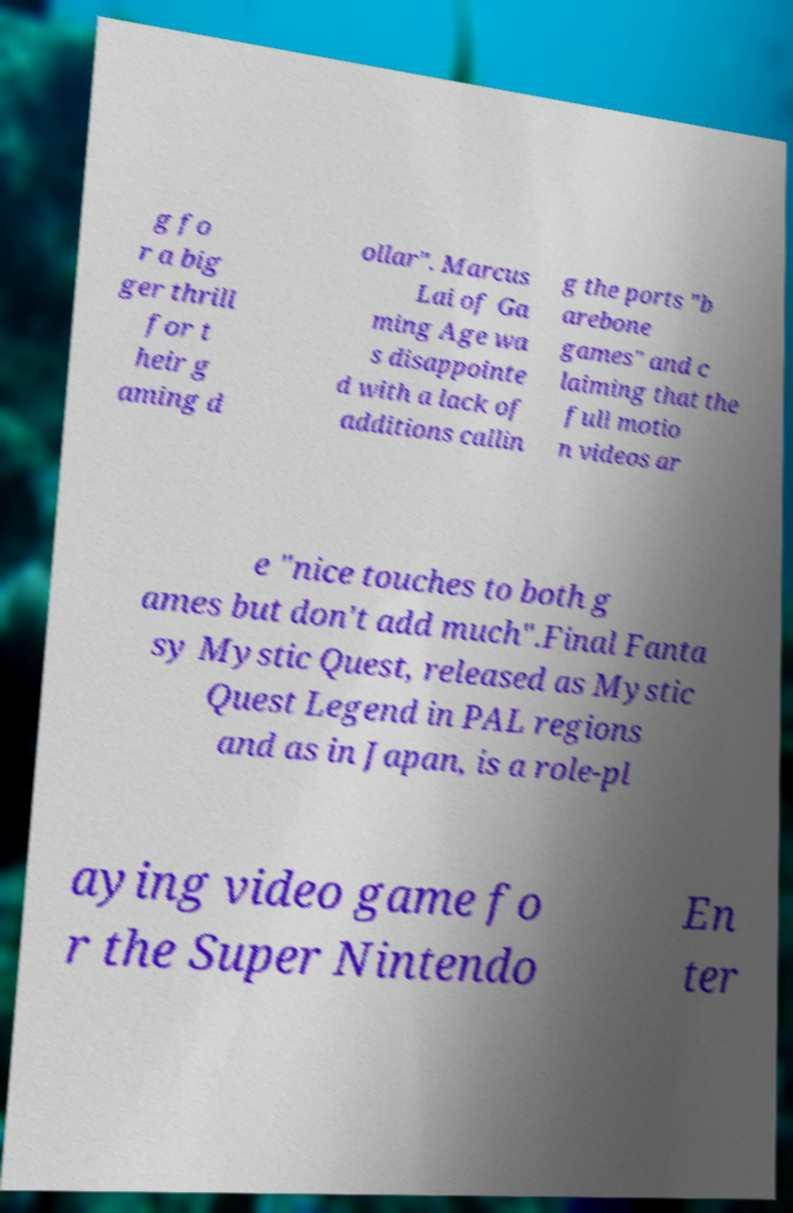Can you accurately transcribe the text from the provided image for me? g fo r a big ger thrill for t heir g aming d ollar". Marcus Lai of Ga ming Age wa s disappointe d with a lack of additions callin g the ports "b arebone games" and c laiming that the full motio n videos ar e "nice touches to both g ames but don't add much".Final Fanta sy Mystic Quest, released as Mystic Quest Legend in PAL regions and as in Japan, is a role-pl aying video game fo r the Super Nintendo En ter 